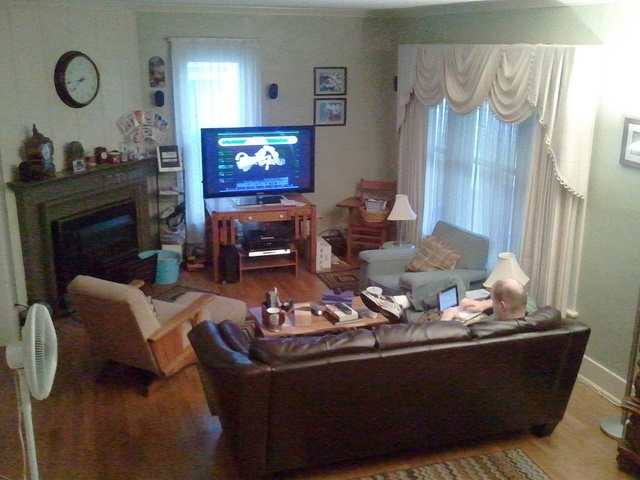Describe the objects in this image and their specific colors. I can see couch in gray, black, maroon, and darkgray tones, chair in gray, maroon, and black tones, tv in gray, blue, navy, white, and lightblue tones, chair in gray tones, and chair in gray, maroon, brown, and black tones in this image. 